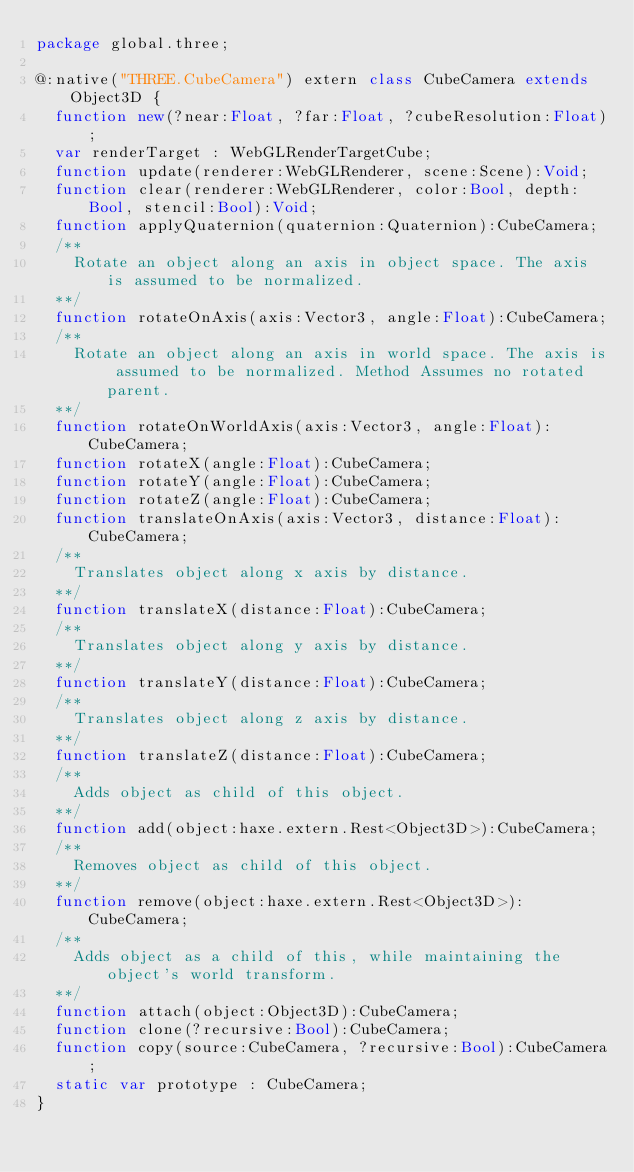<code> <loc_0><loc_0><loc_500><loc_500><_Haxe_>package global.three;

@:native("THREE.CubeCamera") extern class CubeCamera extends Object3D {
	function new(?near:Float, ?far:Float, ?cubeResolution:Float);
	var renderTarget : WebGLRenderTargetCube;
	function update(renderer:WebGLRenderer, scene:Scene):Void;
	function clear(renderer:WebGLRenderer, color:Bool, depth:Bool, stencil:Bool):Void;
	function applyQuaternion(quaternion:Quaternion):CubeCamera;
	/**
		Rotate an object along an axis in object space. The axis is assumed to be normalized.
	**/
	function rotateOnAxis(axis:Vector3, angle:Float):CubeCamera;
	/**
		Rotate an object along an axis in world space. The axis is assumed to be normalized. Method Assumes no rotated parent.
	**/
	function rotateOnWorldAxis(axis:Vector3, angle:Float):CubeCamera;
	function rotateX(angle:Float):CubeCamera;
	function rotateY(angle:Float):CubeCamera;
	function rotateZ(angle:Float):CubeCamera;
	function translateOnAxis(axis:Vector3, distance:Float):CubeCamera;
	/**
		Translates object along x axis by distance.
	**/
	function translateX(distance:Float):CubeCamera;
	/**
		Translates object along y axis by distance.
	**/
	function translateY(distance:Float):CubeCamera;
	/**
		Translates object along z axis by distance.
	**/
	function translateZ(distance:Float):CubeCamera;
	/**
		Adds object as child of this object.
	**/
	function add(object:haxe.extern.Rest<Object3D>):CubeCamera;
	/**
		Removes object as child of this object.
	**/
	function remove(object:haxe.extern.Rest<Object3D>):CubeCamera;
	/**
		Adds object as a child of this, while maintaining the object's world transform.
	**/
	function attach(object:Object3D):CubeCamera;
	function clone(?recursive:Bool):CubeCamera;
	function copy(source:CubeCamera, ?recursive:Bool):CubeCamera;
	static var prototype : CubeCamera;
}</code> 